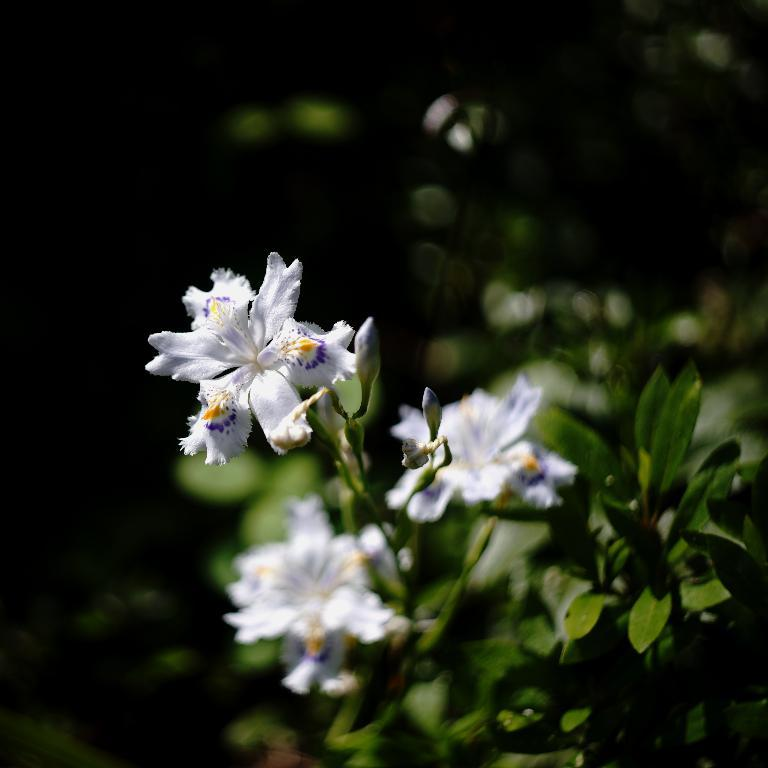What color are the flowers in the image? The flowers in the image are white. What color are the leaves in the image? The leaves in the image are green. What type of cracker is hanging from the curtain in the image? There is no cracker or curtain present in the image; it features white flowers and green leaves. What kind of field can be seen in the background of the image? There is no field visible in the image; it only shows white flowers and green leaves. 